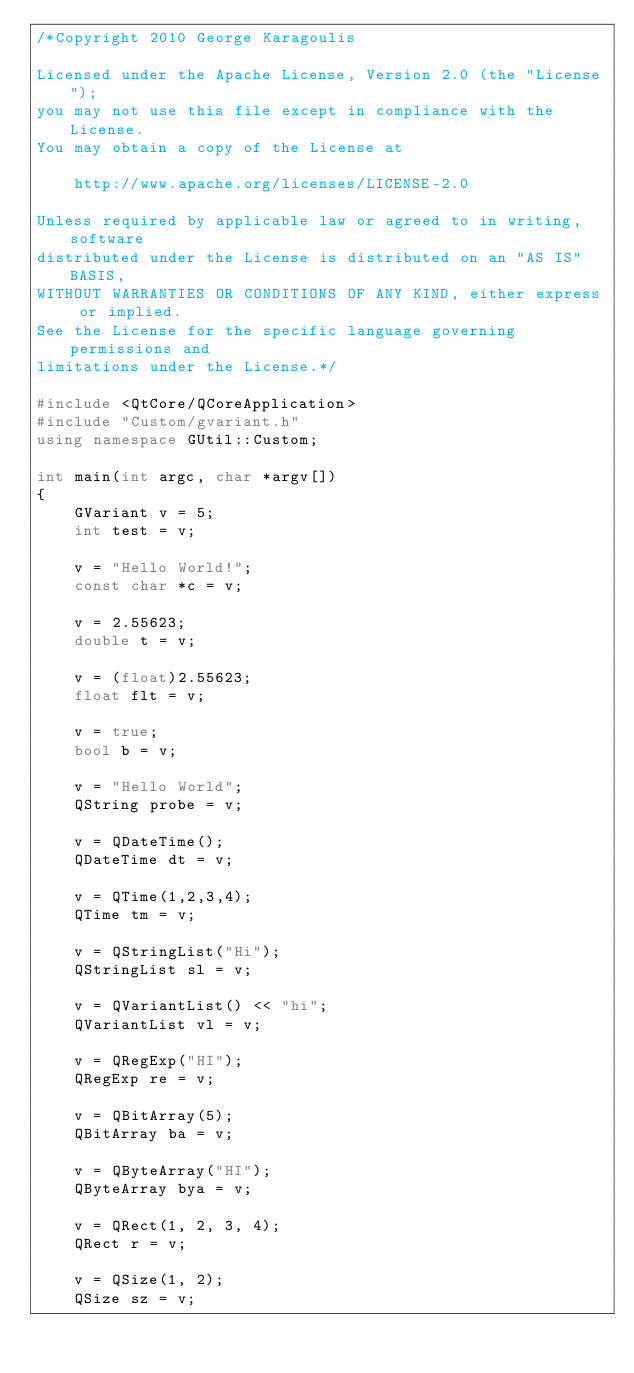<code> <loc_0><loc_0><loc_500><loc_500><_C++_>/*Copyright 2010 George Karagoulis

Licensed under the Apache License, Version 2.0 (the "License");
you may not use this file except in compliance with the License.
You may obtain a copy of the License at

    http://www.apache.org/licenses/LICENSE-2.0

Unless required by applicable law or agreed to in writing, software
distributed under the License is distributed on an "AS IS" BASIS,
WITHOUT WARRANTIES OR CONDITIONS OF ANY KIND, either express or implied.
See the License for the specific language governing permissions and
limitations under the License.*/

#include <QtCore/QCoreApplication>
#include "Custom/gvariant.h"
using namespace GUtil::Custom;

int main(int argc, char *argv[])
{
    GVariant v = 5;
    int test = v;

    v = "Hello World!";
    const char *c = v;

    v = 2.55623;
    double t = v;

    v = (float)2.55623;
    float flt = v;

    v = true;
    bool b = v;

    v = "Hello World";
    QString probe = v;

    v = QDateTime();
    QDateTime dt = v;

    v = QTime(1,2,3,4);
    QTime tm = v;

    v = QStringList("Hi");
    QStringList sl = v;

    v = QVariantList() << "hi";
    QVariantList vl = v;

    v = QRegExp("HI");
    QRegExp re = v;

    v = QBitArray(5);
    QBitArray ba = v;

    v = QByteArray("HI");
    QByteArray bya = v;

    v = QRect(1, 2, 3, 4);
    QRect r = v;

    v = QSize(1, 2);
    QSize sz = v;
</code> 